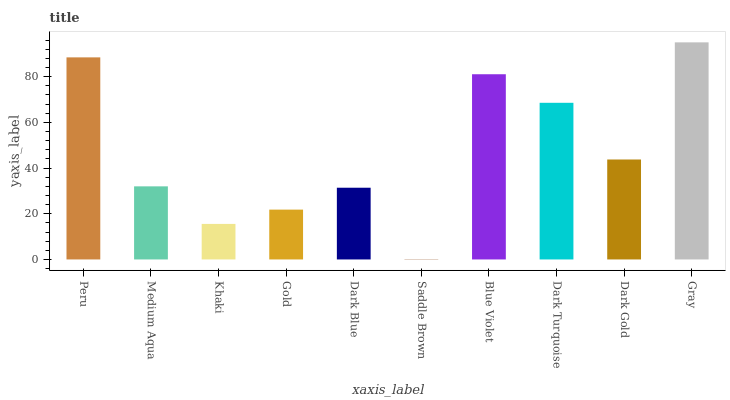Is Saddle Brown the minimum?
Answer yes or no. Yes. Is Gray the maximum?
Answer yes or no. Yes. Is Medium Aqua the minimum?
Answer yes or no. No. Is Medium Aqua the maximum?
Answer yes or no. No. Is Peru greater than Medium Aqua?
Answer yes or no. Yes. Is Medium Aqua less than Peru?
Answer yes or no. Yes. Is Medium Aqua greater than Peru?
Answer yes or no. No. Is Peru less than Medium Aqua?
Answer yes or no. No. Is Dark Gold the high median?
Answer yes or no. Yes. Is Medium Aqua the low median?
Answer yes or no. Yes. Is Dark Blue the high median?
Answer yes or no. No. Is Peru the low median?
Answer yes or no. No. 